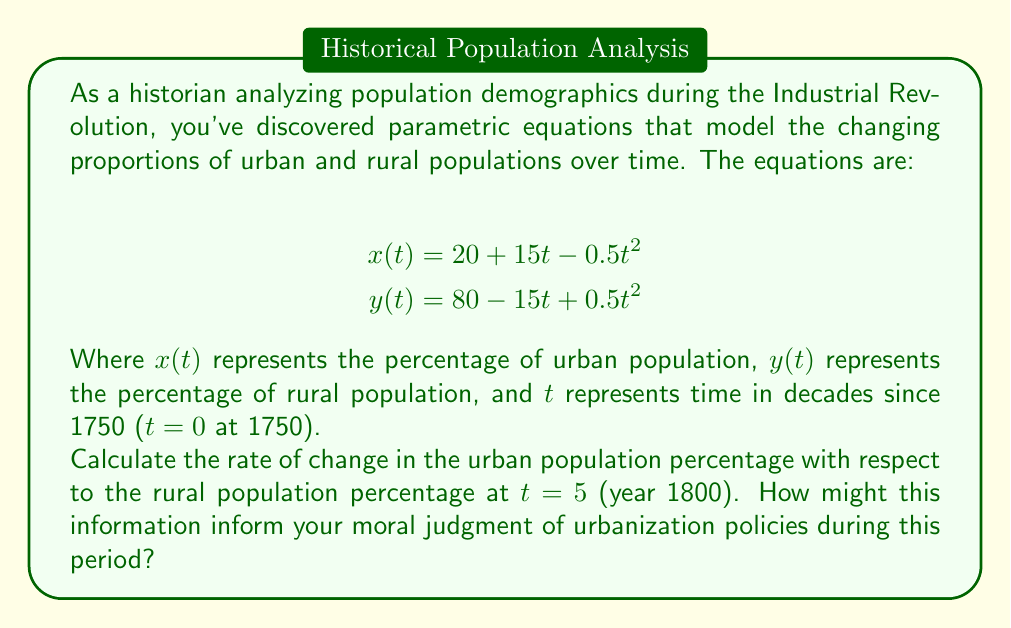Can you solve this math problem? To solve this problem, we need to find $\frac{dx}{dy}$ at t = 5. This represents the rate of change of the urban population percentage with respect to the rural population percentage.

Step 1: Calculate $\frac{dx}{dt}$ and $\frac{dy}{dt}$
$$\frac{dx}{dt} = 15 - t$$
$$\frac{dy}{dt} = -15 + t$$

Step 2: Use the chain rule to find $\frac{dx}{dy}$
$$\frac{dx}{dy} = \frac{dx/dt}{dy/dt} = \frac{15 - t}{-15 + t}$$

Step 3: Evaluate at t = 5
$$\frac{dx}{dy} = \frac{15 - 5}{-15 + 5} = \frac{10}{-10} = -1$$

The negative value indicates that as the rural population decreases, the urban population increases at the same rate.

This result shows that in 1800, for every percentage point decrease in the rural population, there was a corresponding one percentage point increase in the urban population. This rapid urbanization rate might inform moral judgments about policies that encouraged or forced rural-to-urban migration, considering factors such as living conditions, labor rights, and social upheaval during this period of industrialization.
Answer: The rate of change of urban population percentage with respect to rural population percentage at t = 5 (year 1800) is $-1$ or $-100\%$. 